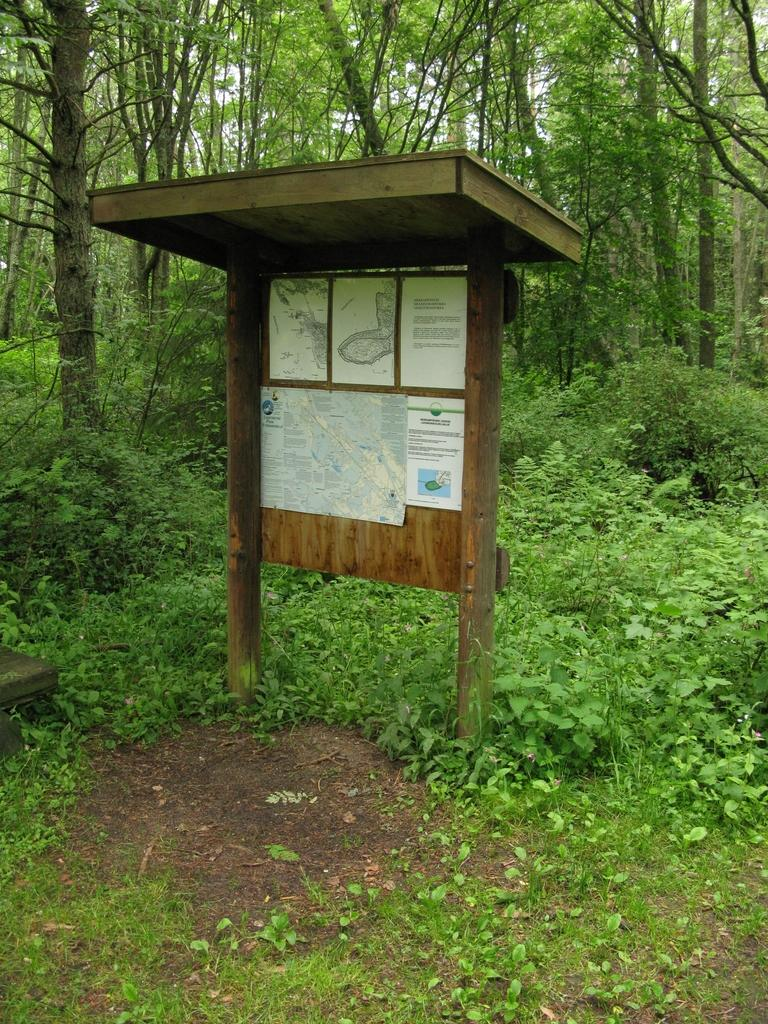What type of vegetation can be seen in the image? There are plants, grass, and trees in the image. What material is the wooden object made of? The wooden object in the image is made of wood. What is attached to the board in the image? There are papers attached to the board in the image. What type of mist can be seen surrounding the plants in the image? There is no mist present in the image; it features plants, grass, trees, a wooden object, and a board with papers attached. What items are on the list that is visible in the image? There is no list present in the image; it features plants, grass, trees, a wooden object, and a board with papers attached. 